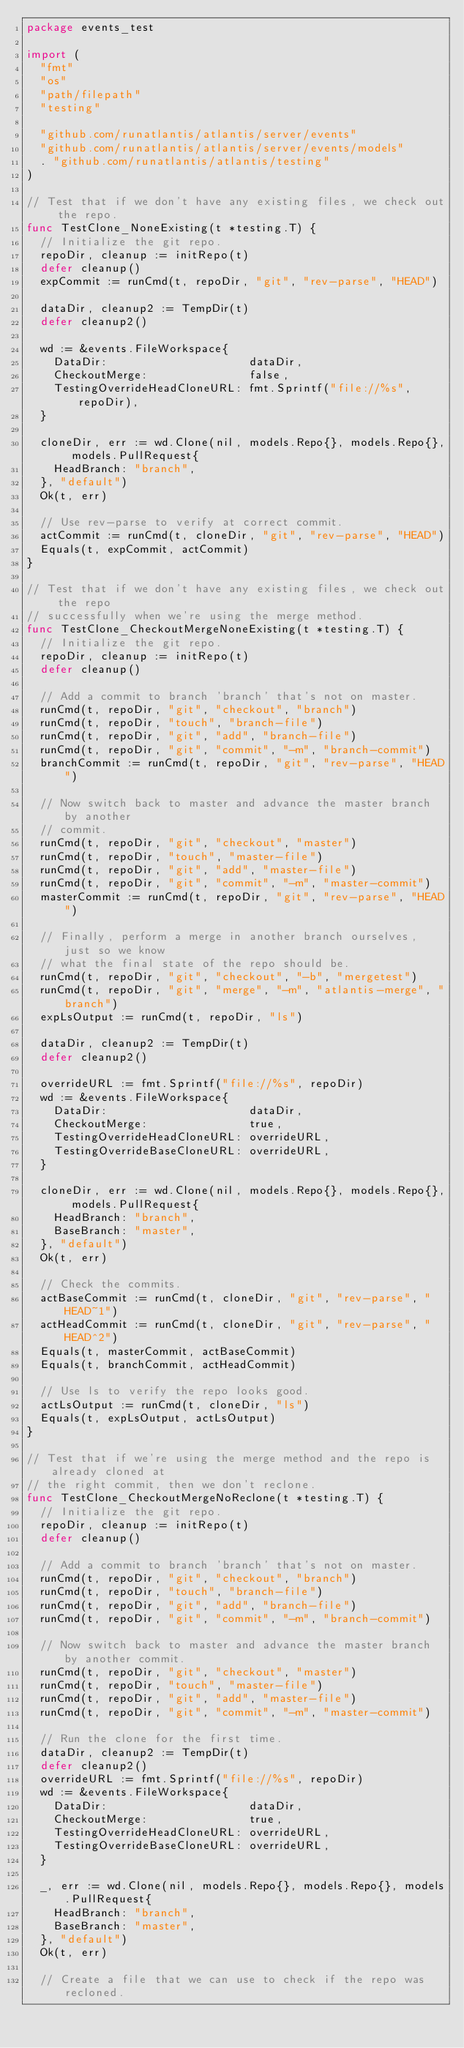<code> <loc_0><loc_0><loc_500><loc_500><_Go_>package events_test

import (
	"fmt"
	"os"
	"path/filepath"
	"testing"

	"github.com/runatlantis/atlantis/server/events"
	"github.com/runatlantis/atlantis/server/events/models"
	. "github.com/runatlantis/atlantis/testing"
)

// Test that if we don't have any existing files, we check out the repo.
func TestClone_NoneExisting(t *testing.T) {
	// Initialize the git repo.
	repoDir, cleanup := initRepo(t)
	defer cleanup()
	expCommit := runCmd(t, repoDir, "git", "rev-parse", "HEAD")

	dataDir, cleanup2 := TempDir(t)
	defer cleanup2()

	wd := &events.FileWorkspace{
		DataDir:                     dataDir,
		CheckoutMerge:               false,
		TestingOverrideHeadCloneURL: fmt.Sprintf("file://%s", repoDir),
	}

	cloneDir, err := wd.Clone(nil, models.Repo{}, models.Repo{}, models.PullRequest{
		HeadBranch: "branch",
	}, "default")
	Ok(t, err)

	// Use rev-parse to verify at correct commit.
	actCommit := runCmd(t, cloneDir, "git", "rev-parse", "HEAD")
	Equals(t, expCommit, actCommit)
}

// Test that if we don't have any existing files, we check out the repo
// successfully when we're using the merge method.
func TestClone_CheckoutMergeNoneExisting(t *testing.T) {
	// Initialize the git repo.
	repoDir, cleanup := initRepo(t)
	defer cleanup()

	// Add a commit to branch 'branch' that's not on master.
	runCmd(t, repoDir, "git", "checkout", "branch")
	runCmd(t, repoDir, "touch", "branch-file")
	runCmd(t, repoDir, "git", "add", "branch-file")
	runCmd(t, repoDir, "git", "commit", "-m", "branch-commit")
	branchCommit := runCmd(t, repoDir, "git", "rev-parse", "HEAD")

	// Now switch back to master and advance the master branch by another
	// commit.
	runCmd(t, repoDir, "git", "checkout", "master")
	runCmd(t, repoDir, "touch", "master-file")
	runCmd(t, repoDir, "git", "add", "master-file")
	runCmd(t, repoDir, "git", "commit", "-m", "master-commit")
	masterCommit := runCmd(t, repoDir, "git", "rev-parse", "HEAD")

	// Finally, perform a merge in another branch ourselves, just so we know
	// what the final state of the repo should be.
	runCmd(t, repoDir, "git", "checkout", "-b", "mergetest")
	runCmd(t, repoDir, "git", "merge", "-m", "atlantis-merge", "branch")
	expLsOutput := runCmd(t, repoDir, "ls")

	dataDir, cleanup2 := TempDir(t)
	defer cleanup2()

	overrideURL := fmt.Sprintf("file://%s", repoDir)
	wd := &events.FileWorkspace{
		DataDir:                     dataDir,
		CheckoutMerge:               true,
		TestingOverrideHeadCloneURL: overrideURL,
		TestingOverrideBaseCloneURL: overrideURL,
	}

	cloneDir, err := wd.Clone(nil, models.Repo{}, models.Repo{}, models.PullRequest{
		HeadBranch: "branch",
		BaseBranch: "master",
	}, "default")
	Ok(t, err)

	// Check the commits.
	actBaseCommit := runCmd(t, cloneDir, "git", "rev-parse", "HEAD~1")
	actHeadCommit := runCmd(t, cloneDir, "git", "rev-parse", "HEAD^2")
	Equals(t, masterCommit, actBaseCommit)
	Equals(t, branchCommit, actHeadCommit)

	// Use ls to verify the repo looks good.
	actLsOutput := runCmd(t, cloneDir, "ls")
	Equals(t, expLsOutput, actLsOutput)
}

// Test that if we're using the merge method and the repo is already cloned at
// the right commit, then we don't reclone.
func TestClone_CheckoutMergeNoReclone(t *testing.T) {
	// Initialize the git repo.
	repoDir, cleanup := initRepo(t)
	defer cleanup()

	// Add a commit to branch 'branch' that's not on master.
	runCmd(t, repoDir, "git", "checkout", "branch")
	runCmd(t, repoDir, "touch", "branch-file")
	runCmd(t, repoDir, "git", "add", "branch-file")
	runCmd(t, repoDir, "git", "commit", "-m", "branch-commit")

	// Now switch back to master and advance the master branch by another commit.
	runCmd(t, repoDir, "git", "checkout", "master")
	runCmd(t, repoDir, "touch", "master-file")
	runCmd(t, repoDir, "git", "add", "master-file")
	runCmd(t, repoDir, "git", "commit", "-m", "master-commit")

	// Run the clone for the first time.
	dataDir, cleanup2 := TempDir(t)
	defer cleanup2()
	overrideURL := fmt.Sprintf("file://%s", repoDir)
	wd := &events.FileWorkspace{
		DataDir:                     dataDir,
		CheckoutMerge:               true,
		TestingOverrideHeadCloneURL: overrideURL,
		TestingOverrideBaseCloneURL: overrideURL,
	}

	_, err := wd.Clone(nil, models.Repo{}, models.Repo{}, models.PullRequest{
		HeadBranch: "branch",
		BaseBranch: "master",
	}, "default")
	Ok(t, err)

	// Create a file that we can use to check if the repo was recloned.</code> 